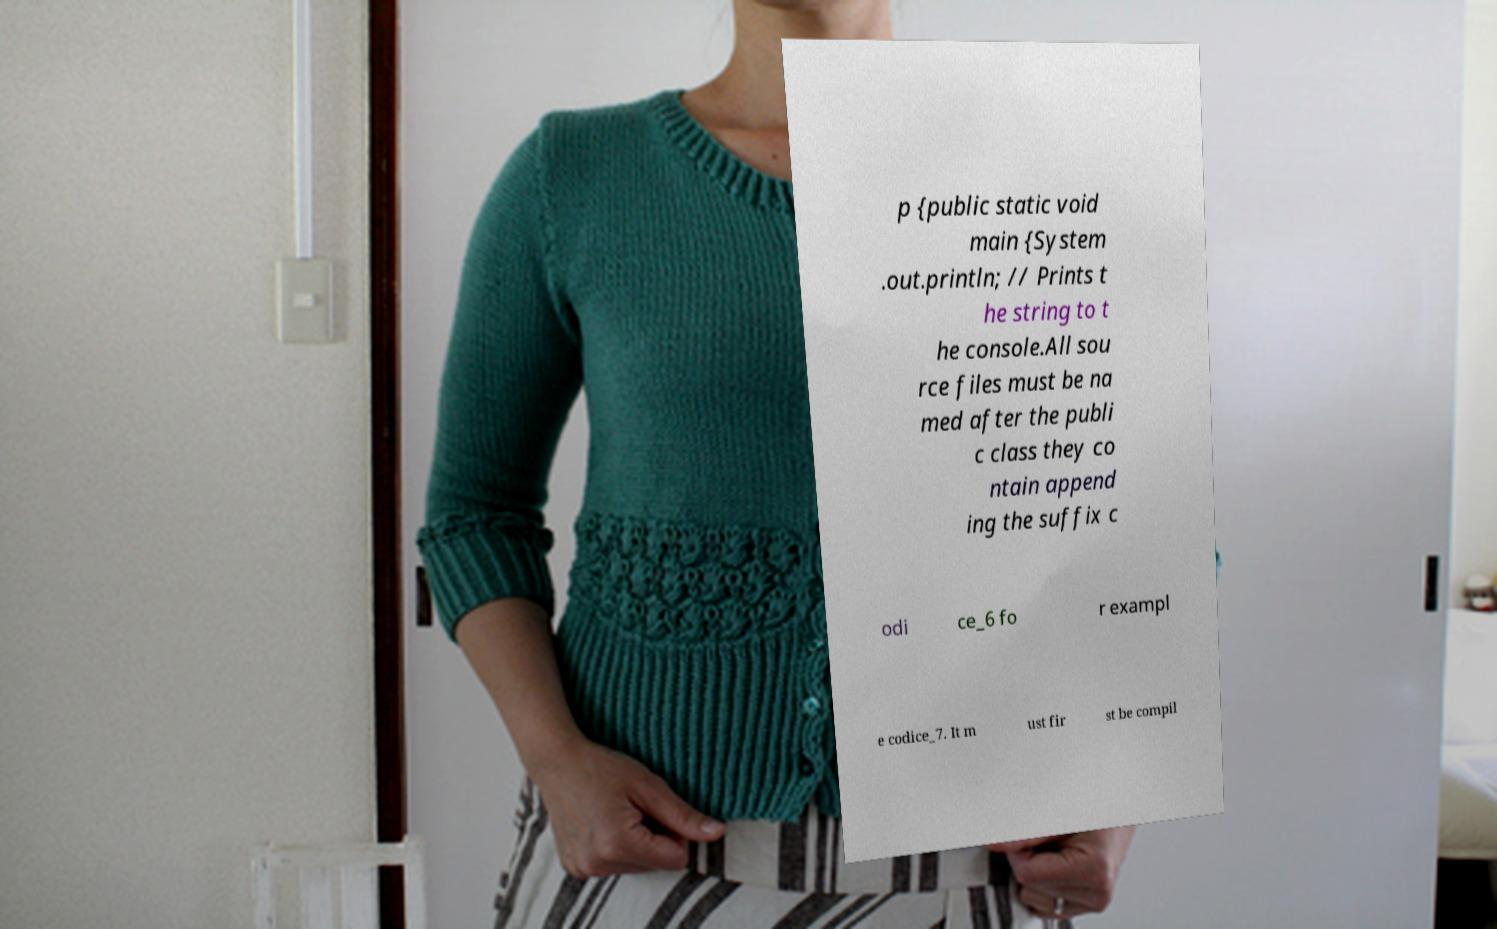Please read and relay the text visible in this image. What does it say? p {public static void main {System .out.println; // Prints t he string to t he console.All sou rce files must be na med after the publi c class they co ntain append ing the suffix c odi ce_6 fo r exampl e codice_7. It m ust fir st be compil 